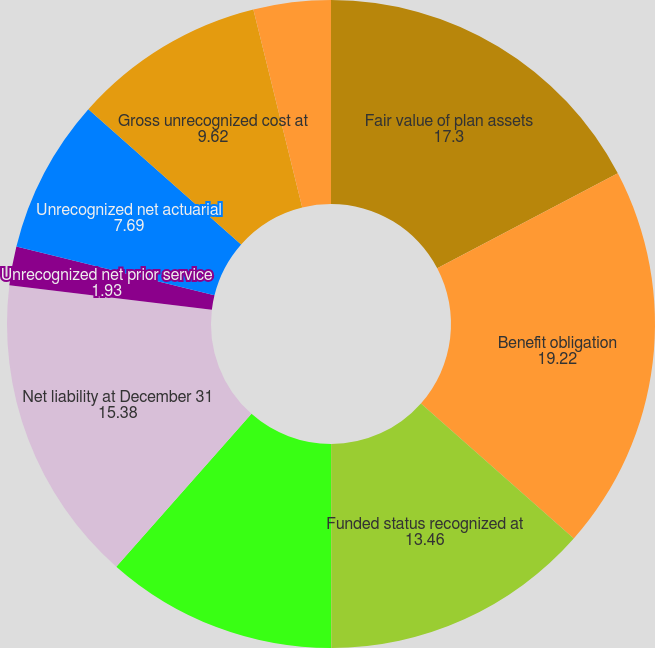Convert chart. <chart><loc_0><loc_0><loc_500><loc_500><pie_chart><fcel>Fair value of plan assets<fcel>Benefit obligation<fcel>Funded status recognized at<fcel>Other current liabilities<fcel>Pension and postretirement<fcel>Net liability at December 31<fcel>Unrecognized net prior service<fcel>Unrecognized net actuarial<fcel>Gross unrecognized cost at<fcel>Deferred tax asset at December<nl><fcel>17.3%<fcel>19.22%<fcel>13.46%<fcel>0.01%<fcel>11.54%<fcel>15.38%<fcel>1.93%<fcel>7.69%<fcel>9.62%<fcel>3.85%<nl></chart> 